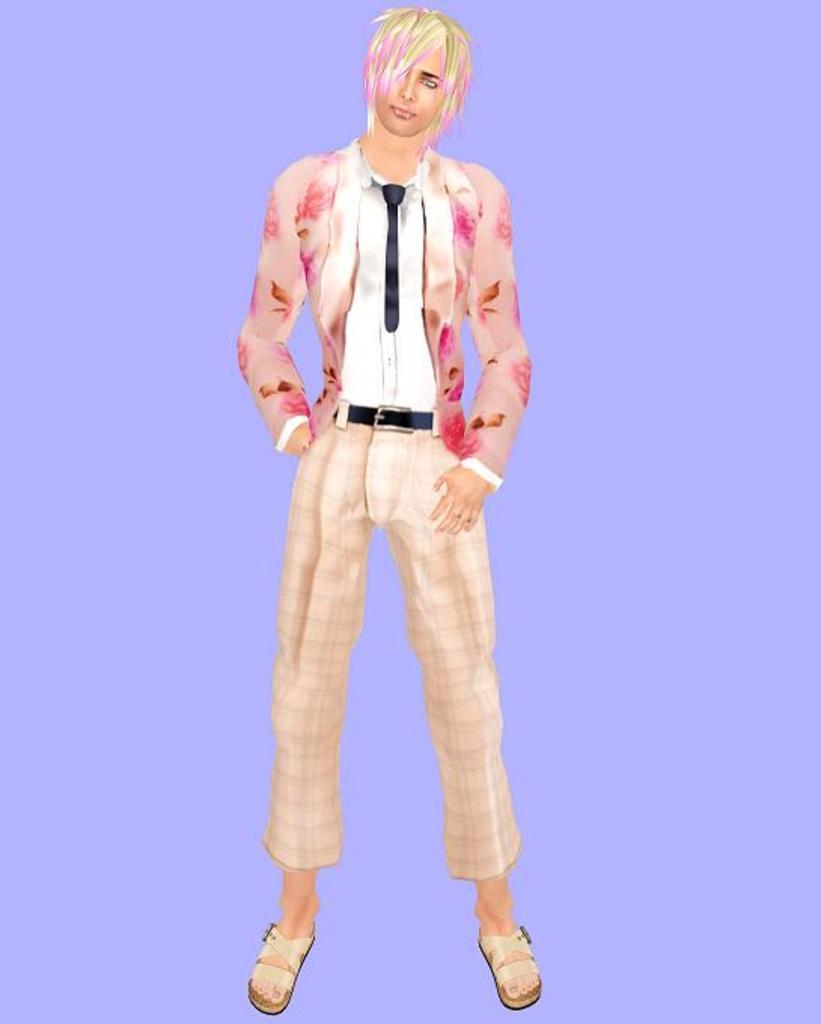What type of character is in the image? There is an animated person in the image. What color is the background of the image? The background of the image is purple. How many swings can be seen in the image? There are no swings present in the image. How long does it take for the animated person to complete a task in the image? The provided facts do not give any information about the animated person's actions or the duration of any tasks, so we cannot answer this question. 